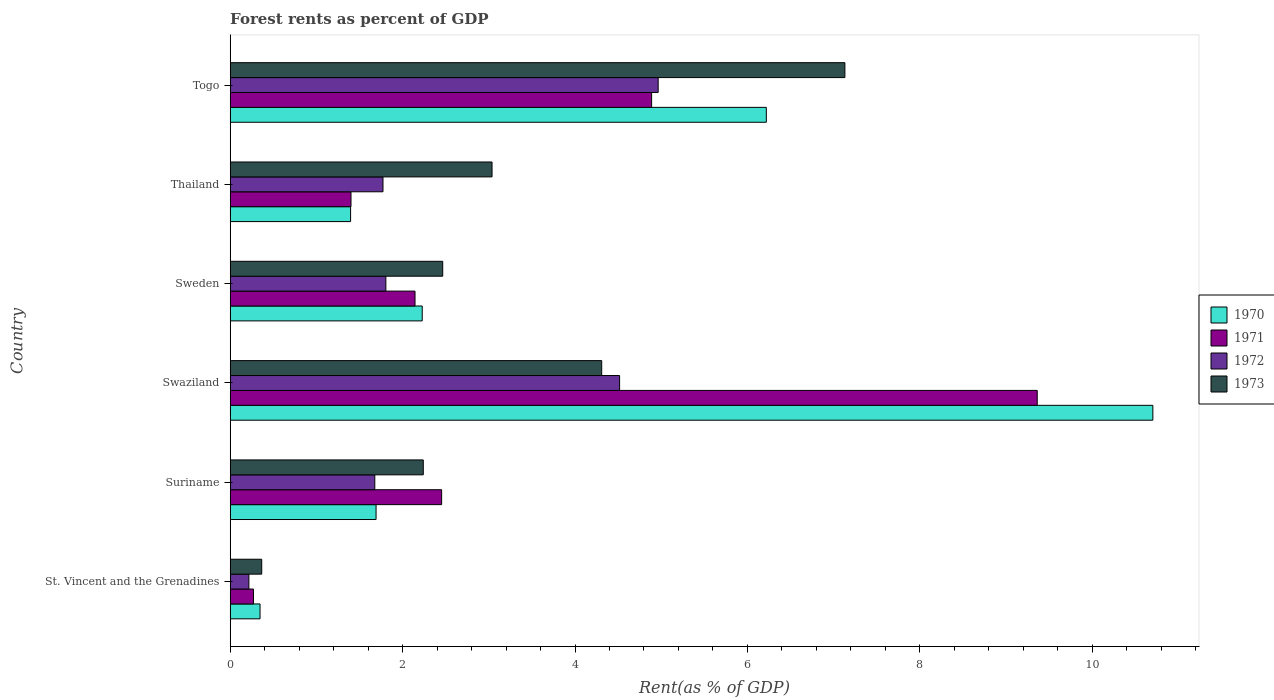How many different coloured bars are there?
Your answer should be very brief. 4. How many groups of bars are there?
Make the answer very short. 6. How many bars are there on the 2nd tick from the bottom?
Offer a very short reply. 4. What is the label of the 4th group of bars from the top?
Keep it short and to the point. Swaziland. In how many cases, is the number of bars for a given country not equal to the number of legend labels?
Give a very brief answer. 0. What is the forest rent in 1973 in St. Vincent and the Grenadines?
Give a very brief answer. 0.37. Across all countries, what is the maximum forest rent in 1970?
Your answer should be very brief. 10.7. Across all countries, what is the minimum forest rent in 1971?
Ensure brevity in your answer.  0.27. In which country was the forest rent in 1972 maximum?
Your answer should be very brief. Togo. In which country was the forest rent in 1972 minimum?
Give a very brief answer. St. Vincent and the Grenadines. What is the total forest rent in 1970 in the graph?
Offer a very short reply. 22.58. What is the difference between the forest rent in 1970 in Suriname and that in Sweden?
Give a very brief answer. -0.54. What is the difference between the forest rent in 1971 in Togo and the forest rent in 1972 in St. Vincent and the Grenadines?
Offer a terse response. 4.67. What is the average forest rent in 1973 per country?
Your answer should be compact. 3.26. What is the difference between the forest rent in 1971 and forest rent in 1970 in Togo?
Give a very brief answer. -1.33. What is the ratio of the forest rent in 1972 in Suriname to that in Swaziland?
Offer a terse response. 0.37. Is the forest rent in 1970 in St. Vincent and the Grenadines less than that in Suriname?
Provide a succinct answer. Yes. What is the difference between the highest and the second highest forest rent in 1970?
Offer a very short reply. 4.48. What is the difference between the highest and the lowest forest rent in 1972?
Your answer should be compact. 4.75. Is it the case that in every country, the sum of the forest rent in 1970 and forest rent in 1971 is greater than the sum of forest rent in 1973 and forest rent in 1972?
Your response must be concise. No. What does the 3rd bar from the bottom in Togo represents?
Offer a terse response. 1972. Is it the case that in every country, the sum of the forest rent in 1970 and forest rent in 1973 is greater than the forest rent in 1971?
Give a very brief answer. Yes. How many bars are there?
Keep it short and to the point. 24. How many countries are there in the graph?
Make the answer very short. 6. Are the values on the major ticks of X-axis written in scientific E-notation?
Your answer should be very brief. No. Does the graph contain grids?
Provide a short and direct response. No. How many legend labels are there?
Make the answer very short. 4. How are the legend labels stacked?
Ensure brevity in your answer.  Vertical. What is the title of the graph?
Provide a succinct answer. Forest rents as percent of GDP. Does "1973" appear as one of the legend labels in the graph?
Your answer should be very brief. Yes. What is the label or title of the X-axis?
Your answer should be compact. Rent(as % of GDP). What is the label or title of the Y-axis?
Provide a short and direct response. Country. What is the Rent(as % of GDP) of 1970 in St. Vincent and the Grenadines?
Offer a terse response. 0.35. What is the Rent(as % of GDP) of 1971 in St. Vincent and the Grenadines?
Keep it short and to the point. 0.27. What is the Rent(as % of GDP) in 1972 in St. Vincent and the Grenadines?
Offer a very short reply. 0.22. What is the Rent(as % of GDP) in 1973 in St. Vincent and the Grenadines?
Provide a short and direct response. 0.37. What is the Rent(as % of GDP) in 1970 in Suriname?
Make the answer very short. 1.69. What is the Rent(as % of GDP) in 1971 in Suriname?
Provide a short and direct response. 2.45. What is the Rent(as % of GDP) in 1972 in Suriname?
Offer a terse response. 1.68. What is the Rent(as % of GDP) in 1973 in Suriname?
Give a very brief answer. 2.24. What is the Rent(as % of GDP) in 1970 in Swaziland?
Keep it short and to the point. 10.7. What is the Rent(as % of GDP) of 1971 in Swaziland?
Keep it short and to the point. 9.36. What is the Rent(as % of GDP) in 1972 in Swaziland?
Offer a very short reply. 4.52. What is the Rent(as % of GDP) of 1973 in Swaziland?
Make the answer very short. 4.31. What is the Rent(as % of GDP) in 1970 in Sweden?
Keep it short and to the point. 2.23. What is the Rent(as % of GDP) of 1971 in Sweden?
Give a very brief answer. 2.14. What is the Rent(as % of GDP) of 1972 in Sweden?
Offer a very short reply. 1.81. What is the Rent(as % of GDP) of 1973 in Sweden?
Ensure brevity in your answer.  2.47. What is the Rent(as % of GDP) in 1970 in Thailand?
Your response must be concise. 1.4. What is the Rent(as % of GDP) in 1971 in Thailand?
Provide a succinct answer. 1.4. What is the Rent(as % of GDP) of 1972 in Thailand?
Your answer should be compact. 1.77. What is the Rent(as % of GDP) in 1973 in Thailand?
Offer a very short reply. 3.04. What is the Rent(as % of GDP) in 1970 in Togo?
Provide a short and direct response. 6.22. What is the Rent(as % of GDP) in 1971 in Togo?
Provide a succinct answer. 4.89. What is the Rent(as % of GDP) in 1972 in Togo?
Provide a short and direct response. 4.96. What is the Rent(as % of GDP) of 1973 in Togo?
Keep it short and to the point. 7.13. Across all countries, what is the maximum Rent(as % of GDP) in 1970?
Give a very brief answer. 10.7. Across all countries, what is the maximum Rent(as % of GDP) in 1971?
Keep it short and to the point. 9.36. Across all countries, what is the maximum Rent(as % of GDP) in 1972?
Offer a very short reply. 4.96. Across all countries, what is the maximum Rent(as % of GDP) in 1973?
Keep it short and to the point. 7.13. Across all countries, what is the minimum Rent(as % of GDP) in 1970?
Your answer should be compact. 0.35. Across all countries, what is the minimum Rent(as % of GDP) in 1971?
Ensure brevity in your answer.  0.27. Across all countries, what is the minimum Rent(as % of GDP) of 1972?
Your response must be concise. 0.22. Across all countries, what is the minimum Rent(as % of GDP) of 1973?
Your answer should be compact. 0.37. What is the total Rent(as % of GDP) in 1970 in the graph?
Make the answer very short. 22.58. What is the total Rent(as % of GDP) in 1971 in the graph?
Offer a very short reply. 20.52. What is the total Rent(as % of GDP) in 1972 in the graph?
Provide a succinct answer. 14.95. What is the total Rent(as % of GDP) of 1973 in the graph?
Your response must be concise. 19.55. What is the difference between the Rent(as % of GDP) of 1970 in St. Vincent and the Grenadines and that in Suriname?
Give a very brief answer. -1.35. What is the difference between the Rent(as % of GDP) of 1971 in St. Vincent and the Grenadines and that in Suriname?
Your answer should be compact. -2.18. What is the difference between the Rent(as % of GDP) of 1972 in St. Vincent and the Grenadines and that in Suriname?
Your answer should be compact. -1.46. What is the difference between the Rent(as % of GDP) of 1973 in St. Vincent and the Grenadines and that in Suriname?
Ensure brevity in your answer.  -1.87. What is the difference between the Rent(as % of GDP) in 1970 in St. Vincent and the Grenadines and that in Swaziland?
Make the answer very short. -10.36. What is the difference between the Rent(as % of GDP) of 1971 in St. Vincent and the Grenadines and that in Swaziland?
Provide a succinct answer. -9.09. What is the difference between the Rent(as % of GDP) in 1972 in St. Vincent and the Grenadines and that in Swaziland?
Provide a succinct answer. -4.3. What is the difference between the Rent(as % of GDP) in 1973 in St. Vincent and the Grenadines and that in Swaziland?
Give a very brief answer. -3.94. What is the difference between the Rent(as % of GDP) of 1970 in St. Vincent and the Grenadines and that in Sweden?
Your response must be concise. -1.88. What is the difference between the Rent(as % of GDP) of 1971 in St. Vincent and the Grenadines and that in Sweden?
Your response must be concise. -1.87. What is the difference between the Rent(as % of GDP) in 1972 in St. Vincent and the Grenadines and that in Sweden?
Ensure brevity in your answer.  -1.59. What is the difference between the Rent(as % of GDP) in 1973 in St. Vincent and the Grenadines and that in Sweden?
Provide a short and direct response. -2.1. What is the difference between the Rent(as % of GDP) of 1970 in St. Vincent and the Grenadines and that in Thailand?
Offer a very short reply. -1.05. What is the difference between the Rent(as % of GDP) of 1971 in St. Vincent and the Grenadines and that in Thailand?
Your answer should be very brief. -1.13. What is the difference between the Rent(as % of GDP) in 1972 in St. Vincent and the Grenadines and that in Thailand?
Give a very brief answer. -1.56. What is the difference between the Rent(as % of GDP) in 1973 in St. Vincent and the Grenadines and that in Thailand?
Ensure brevity in your answer.  -2.67. What is the difference between the Rent(as % of GDP) of 1970 in St. Vincent and the Grenadines and that in Togo?
Your response must be concise. -5.87. What is the difference between the Rent(as % of GDP) in 1971 in St. Vincent and the Grenadines and that in Togo?
Your answer should be very brief. -4.62. What is the difference between the Rent(as % of GDP) in 1972 in St. Vincent and the Grenadines and that in Togo?
Make the answer very short. -4.75. What is the difference between the Rent(as % of GDP) in 1973 in St. Vincent and the Grenadines and that in Togo?
Provide a succinct answer. -6.76. What is the difference between the Rent(as % of GDP) in 1970 in Suriname and that in Swaziland?
Offer a terse response. -9.01. What is the difference between the Rent(as % of GDP) of 1971 in Suriname and that in Swaziland?
Offer a very short reply. -6.91. What is the difference between the Rent(as % of GDP) of 1972 in Suriname and that in Swaziland?
Offer a very short reply. -2.84. What is the difference between the Rent(as % of GDP) of 1973 in Suriname and that in Swaziland?
Ensure brevity in your answer.  -2.07. What is the difference between the Rent(as % of GDP) in 1970 in Suriname and that in Sweden?
Your response must be concise. -0.54. What is the difference between the Rent(as % of GDP) of 1971 in Suriname and that in Sweden?
Provide a succinct answer. 0.31. What is the difference between the Rent(as % of GDP) of 1972 in Suriname and that in Sweden?
Give a very brief answer. -0.13. What is the difference between the Rent(as % of GDP) in 1973 in Suriname and that in Sweden?
Keep it short and to the point. -0.23. What is the difference between the Rent(as % of GDP) of 1970 in Suriname and that in Thailand?
Offer a very short reply. 0.3. What is the difference between the Rent(as % of GDP) of 1971 in Suriname and that in Thailand?
Your answer should be compact. 1.05. What is the difference between the Rent(as % of GDP) in 1972 in Suriname and that in Thailand?
Provide a short and direct response. -0.1. What is the difference between the Rent(as % of GDP) of 1973 in Suriname and that in Thailand?
Ensure brevity in your answer.  -0.8. What is the difference between the Rent(as % of GDP) in 1970 in Suriname and that in Togo?
Provide a succinct answer. -4.53. What is the difference between the Rent(as % of GDP) of 1971 in Suriname and that in Togo?
Your response must be concise. -2.44. What is the difference between the Rent(as % of GDP) of 1972 in Suriname and that in Togo?
Offer a very short reply. -3.29. What is the difference between the Rent(as % of GDP) of 1973 in Suriname and that in Togo?
Make the answer very short. -4.89. What is the difference between the Rent(as % of GDP) in 1970 in Swaziland and that in Sweden?
Your response must be concise. 8.48. What is the difference between the Rent(as % of GDP) in 1971 in Swaziland and that in Sweden?
Make the answer very short. 7.22. What is the difference between the Rent(as % of GDP) in 1972 in Swaziland and that in Sweden?
Make the answer very short. 2.71. What is the difference between the Rent(as % of GDP) of 1973 in Swaziland and that in Sweden?
Your answer should be very brief. 1.84. What is the difference between the Rent(as % of GDP) in 1970 in Swaziland and that in Thailand?
Your answer should be compact. 9.31. What is the difference between the Rent(as % of GDP) of 1971 in Swaziland and that in Thailand?
Make the answer very short. 7.96. What is the difference between the Rent(as % of GDP) of 1972 in Swaziland and that in Thailand?
Your response must be concise. 2.74. What is the difference between the Rent(as % of GDP) in 1973 in Swaziland and that in Thailand?
Provide a succinct answer. 1.27. What is the difference between the Rent(as % of GDP) of 1970 in Swaziland and that in Togo?
Give a very brief answer. 4.48. What is the difference between the Rent(as % of GDP) of 1971 in Swaziland and that in Togo?
Ensure brevity in your answer.  4.47. What is the difference between the Rent(as % of GDP) in 1972 in Swaziland and that in Togo?
Offer a very short reply. -0.45. What is the difference between the Rent(as % of GDP) in 1973 in Swaziland and that in Togo?
Provide a short and direct response. -2.82. What is the difference between the Rent(as % of GDP) of 1970 in Sweden and that in Thailand?
Provide a succinct answer. 0.83. What is the difference between the Rent(as % of GDP) of 1971 in Sweden and that in Thailand?
Provide a succinct answer. 0.74. What is the difference between the Rent(as % of GDP) of 1972 in Sweden and that in Thailand?
Provide a succinct answer. 0.03. What is the difference between the Rent(as % of GDP) of 1973 in Sweden and that in Thailand?
Ensure brevity in your answer.  -0.57. What is the difference between the Rent(as % of GDP) in 1970 in Sweden and that in Togo?
Offer a very short reply. -3.99. What is the difference between the Rent(as % of GDP) of 1971 in Sweden and that in Togo?
Offer a very short reply. -2.74. What is the difference between the Rent(as % of GDP) in 1972 in Sweden and that in Togo?
Offer a very short reply. -3.16. What is the difference between the Rent(as % of GDP) of 1973 in Sweden and that in Togo?
Keep it short and to the point. -4.67. What is the difference between the Rent(as % of GDP) in 1970 in Thailand and that in Togo?
Offer a very short reply. -4.82. What is the difference between the Rent(as % of GDP) in 1971 in Thailand and that in Togo?
Provide a succinct answer. -3.49. What is the difference between the Rent(as % of GDP) of 1972 in Thailand and that in Togo?
Your answer should be compact. -3.19. What is the difference between the Rent(as % of GDP) of 1973 in Thailand and that in Togo?
Keep it short and to the point. -4.09. What is the difference between the Rent(as % of GDP) of 1970 in St. Vincent and the Grenadines and the Rent(as % of GDP) of 1971 in Suriname?
Offer a very short reply. -2.11. What is the difference between the Rent(as % of GDP) in 1970 in St. Vincent and the Grenadines and the Rent(as % of GDP) in 1972 in Suriname?
Offer a terse response. -1.33. What is the difference between the Rent(as % of GDP) of 1970 in St. Vincent and the Grenadines and the Rent(as % of GDP) of 1973 in Suriname?
Ensure brevity in your answer.  -1.89. What is the difference between the Rent(as % of GDP) of 1971 in St. Vincent and the Grenadines and the Rent(as % of GDP) of 1972 in Suriname?
Provide a short and direct response. -1.41. What is the difference between the Rent(as % of GDP) in 1971 in St. Vincent and the Grenadines and the Rent(as % of GDP) in 1973 in Suriname?
Make the answer very short. -1.97. What is the difference between the Rent(as % of GDP) of 1972 in St. Vincent and the Grenadines and the Rent(as % of GDP) of 1973 in Suriname?
Keep it short and to the point. -2.02. What is the difference between the Rent(as % of GDP) in 1970 in St. Vincent and the Grenadines and the Rent(as % of GDP) in 1971 in Swaziland?
Ensure brevity in your answer.  -9.02. What is the difference between the Rent(as % of GDP) of 1970 in St. Vincent and the Grenadines and the Rent(as % of GDP) of 1972 in Swaziland?
Provide a succinct answer. -4.17. What is the difference between the Rent(as % of GDP) of 1970 in St. Vincent and the Grenadines and the Rent(as % of GDP) of 1973 in Swaziland?
Provide a succinct answer. -3.96. What is the difference between the Rent(as % of GDP) of 1971 in St. Vincent and the Grenadines and the Rent(as % of GDP) of 1972 in Swaziland?
Your response must be concise. -4.25. What is the difference between the Rent(as % of GDP) in 1971 in St. Vincent and the Grenadines and the Rent(as % of GDP) in 1973 in Swaziland?
Offer a very short reply. -4.04. What is the difference between the Rent(as % of GDP) of 1972 in St. Vincent and the Grenadines and the Rent(as % of GDP) of 1973 in Swaziland?
Your answer should be compact. -4.09. What is the difference between the Rent(as % of GDP) in 1970 in St. Vincent and the Grenadines and the Rent(as % of GDP) in 1971 in Sweden?
Your answer should be compact. -1.8. What is the difference between the Rent(as % of GDP) of 1970 in St. Vincent and the Grenadines and the Rent(as % of GDP) of 1972 in Sweden?
Your response must be concise. -1.46. What is the difference between the Rent(as % of GDP) of 1970 in St. Vincent and the Grenadines and the Rent(as % of GDP) of 1973 in Sweden?
Give a very brief answer. -2.12. What is the difference between the Rent(as % of GDP) in 1971 in St. Vincent and the Grenadines and the Rent(as % of GDP) in 1972 in Sweden?
Your response must be concise. -1.54. What is the difference between the Rent(as % of GDP) of 1971 in St. Vincent and the Grenadines and the Rent(as % of GDP) of 1973 in Sweden?
Offer a very short reply. -2.2. What is the difference between the Rent(as % of GDP) of 1972 in St. Vincent and the Grenadines and the Rent(as % of GDP) of 1973 in Sweden?
Make the answer very short. -2.25. What is the difference between the Rent(as % of GDP) of 1970 in St. Vincent and the Grenadines and the Rent(as % of GDP) of 1971 in Thailand?
Offer a terse response. -1.06. What is the difference between the Rent(as % of GDP) of 1970 in St. Vincent and the Grenadines and the Rent(as % of GDP) of 1972 in Thailand?
Your response must be concise. -1.43. What is the difference between the Rent(as % of GDP) of 1970 in St. Vincent and the Grenadines and the Rent(as % of GDP) of 1973 in Thailand?
Provide a succinct answer. -2.69. What is the difference between the Rent(as % of GDP) of 1971 in St. Vincent and the Grenadines and the Rent(as % of GDP) of 1972 in Thailand?
Provide a succinct answer. -1.5. What is the difference between the Rent(as % of GDP) in 1971 in St. Vincent and the Grenadines and the Rent(as % of GDP) in 1973 in Thailand?
Offer a terse response. -2.77. What is the difference between the Rent(as % of GDP) in 1972 in St. Vincent and the Grenadines and the Rent(as % of GDP) in 1973 in Thailand?
Provide a succinct answer. -2.82. What is the difference between the Rent(as % of GDP) in 1970 in St. Vincent and the Grenadines and the Rent(as % of GDP) in 1971 in Togo?
Provide a short and direct response. -4.54. What is the difference between the Rent(as % of GDP) in 1970 in St. Vincent and the Grenadines and the Rent(as % of GDP) in 1972 in Togo?
Give a very brief answer. -4.62. What is the difference between the Rent(as % of GDP) of 1970 in St. Vincent and the Grenadines and the Rent(as % of GDP) of 1973 in Togo?
Provide a short and direct response. -6.78. What is the difference between the Rent(as % of GDP) of 1971 in St. Vincent and the Grenadines and the Rent(as % of GDP) of 1972 in Togo?
Your answer should be compact. -4.69. What is the difference between the Rent(as % of GDP) in 1971 in St. Vincent and the Grenadines and the Rent(as % of GDP) in 1973 in Togo?
Offer a terse response. -6.86. What is the difference between the Rent(as % of GDP) in 1972 in St. Vincent and the Grenadines and the Rent(as % of GDP) in 1973 in Togo?
Provide a succinct answer. -6.91. What is the difference between the Rent(as % of GDP) in 1970 in Suriname and the Rent(as % of GDP) in 1971 in Swaziland?
Your response must be concise. -7.67. What is the difference between the Rent(as % of GDP) of 1970 in Suriname and the Rent(as % of GDP) of 1972 in Swaziland?
Offer a terse response. -2.82. What is the difference between the Rent(as % of GDP) of 1970 in Suriname and the Rent(as % of GDP) of 1973 in Swaziland?
Your answer should be compact. -2.62. What is the difference between the Rent(as % of GDP) in 1971 in Suriname and the Rent(as % of GDP) in 1972 in Swaziland?
Your response must be concise. -2.06. What is the difference between the Rent(as % of GDP) in 1971 in Suriname and the Rent(as % of GDP) in 1973 in Swaziland?
Give a very brief answer. -1.86. What is the difference between the Rent(as % of GDP) in 1972 in Suriname and the Rent(as % of GDP) in 1973 in Swaziland?
Ensure brevity in your answer.  -2.63. What is the difference between the Rent(as % of GDP) of 1970 in Suriname and the Rent(as % of GDP) of 1971 in Sweden?
Give a very brief answer. -0.45. What is the difference between the Rent(as % of GDP) of 1970 in Suriname and the Rent(as % of GDP) of 1972 in Sweden?
Make the answer very short. -0.11. What is the difference between the Rent(as % of GDP) in 1970 in Suriname and the Rent(as % of GDP) in 1973 in Sweden?
Your answer should be compact. -0.77. What is the difference between the Rent(as % of GDP) of 1971 in Suriname and the Rent(as % of GDP) of 1972 in Sweden?
Offer a terse response. 0.65. What is the difference between the Rent(as % of GDP) in 1971 in Suriname and the Rent(as % of GDP) in 1973 in Sweden?
Offer a very short reply. -0.01. What is the difference between the Rent(as % of GDP) in 1972 in Suriname and the Rent(as % of GDP) in 1973 in Sweden?
Keep it short and to the point. -0.79. What is the difference between the Rent(as % of GDP) of 1970 in Suriname and the Rent(as % of GDP) of 1971 in Thailand?
Your answer should be very brief. 0.29. What is the difference between the Rent(as % of GDP) in 1970 in Suriname and the Rent(as % of GDP) in 1972 in Thailand?
Offer a terse response. -0.08. What is the difference between the Rent(as % of GDP) of 1970 in Suriname and the Rent(as % of GDP) of 1973 in Thailand?
Provide a short and direct response. -1.35. What is the difference between the Rent(as % of GDP) in 1971 in Suriname and the Rent(as % of GDP) in 1972 in Thailand?
Your answer should be compact. 0.68. What is the difference between the Rent(as % of GDP) of 1971 in Suriname and the Rent(as % of GDP) of 1973 in Thailand?
Your response must be concise. -0.58. What is the difference between the Rent(as % of GDP) in 1972 in Suriname and the Rent(as % of GDP) in 1973 in Thailand?
Make the answer very short. -1.36. What is the difference between the Rent(as % of GDP) of 1970 in Suriname and the Rent(as % of GDP) of 1971 in Togo?
Your answer should be very brief. -3.2. What is the difference between the Rent(as % of GDP) in 1970 in Suriname and the Rent(as % of GDP) in 1972 in Togo?
Your response must be concise. -3.27. What is the difference between the Rent(as % of GDP) of 1970 in Suriname and the Rent(as % of GDP) of 1973 in Togo?
Make the answer very short. -5.44. What is the difference between the Rent(as % of GDP) in 1971 in Suriname and the Rent(as % of GDP) in 1972 in Togo?
Ensure brevity in your answer.  -2.51. What is the difference between the Rent(as % of GDP) of 1971 in Suriname and the Rent(as % of GDP) of 1973 in Togo?
Give a very brief answer. -4.68. What is the difference between the Rent(as % of GDP) in 1972 in Suriname and the Rent(as % of GDP) in 1973 in Togo?
Make the answer very short. -5.45. What is the difference between the Rent(as % of GDP) in 1970 in Swaziland and the Rent(as % of GDP) in 1971 in Sweden?
Ensure brevity in your answer.  8.56. What is the difference between the Rent(as % of GDP) in 1970 in Swaziland and the Rent(as % of GDP) in 1972 in Sweden?
Offer a terse response. 8.9. What is the difference between the Rent(as % of GDP) of 1970 in Swaziland and the Rent(as % of GDP) of 1973 in Sweden?
Offer a very short reply. 8.24. What is the difference between the Rent(as % of GDP) of 1971 in Swaziland and the Rent(as % of GDP) of 1972 in Sweden?
Your response must be concise. 7.56. What is the difference between the Rent(as % of GDP) in 1971 in Swaziland and the Rent(as % of GDP) in 1973 in Sweden?
Your answer should be compact. 6.9. What is the difference between the Rent(as % of GDP) of 1972 in Swaziland and the Rent(as % of GDP) of 1973 in Sweden?
Provide a short and direct response. 2.05. What is the difference between the Rent(as % of GDP) of 1970 in Swaziland and the Rent(as % of GDP) of 1971 in Thailand?
Offer a terse response. 9.3. What is the difference between the Rent(as % of GDP) in 1970 in Swaziland and the Rent(as % of GDP) in 1972 in Thailand?
Your answer should be compact. 8.93. What is the difference between the Rent(as % of GDP) in 1970 in Swaziland and the Rent(as % of GDP) in 1973 in Thailand?
Your answer should be very brief. 7.67. What is the difference between the Rent(as % of GDP) of 1971 in Swaziland and the Rent(as % of GDP) of 1972 in Thailand?
Provide a succinct answer. 7.59. What is the difference between the Rent(as % of GDP) in 1971 in Swaziland and the Rent(as % of GDP) in 1973 in Thailand?
Provide a succinct answer. 6.32. What is the difference between the Rent(as % of GDP) of 1972 in Swaziland and the Rent(as % of GDP) of 1973 in Thailand?
Offer a terse response. 1.48. What is the difference between the Rent(as % of GDP) in 1970 in Swaziland and the Rent(as % of GDP) in 1971 in Togo?
Offer a very short reply. 5.81. What is the difference between the Rent(as % of GDP) of 1970 in Swaziland and the Rent(as % of GDP) of 1972 in Togo?
Offer a terse response. 5.74. What is the difference between the Rent(as % of GDP) in 1970 in Swaziland and the Rent(as % of GDP) in 1973 in Togo?
Provide a short and direct response. 3.57. What is the difference between the Rent(as % of GDP) of 1971 in Swaziland and the Rent(as % of GDP) of 1972 in Togo?
Offer a very short reply. 4.4. What is the difference between the Rent(as % of GDP) of 1971 in Swaziland and the Rent(as % of GDP) of 1973 in Togo?
Offer a terse response. 2.23. What is the difference between the Rent(as % of GDP) in 1972 in Swaziland and the Rent(as % of GDP) in 1973 in Togo?
Ensure brevity in your answer.  -2.61. What is the difference between the Rent(as % of GDP) of 1970 in Sweden and the Rent(as % of GDP) of 1971 in Thailand?
Give a very brief answer. 0.83. What is the difference between the Rent(as % of GDP) of 1970 in Sweden and the Rent(as % of GDP) of 1972 in Thailand?
Provide a short and direct response. 0.46. What is the difference between the Rent(as % of GDP) of 1970 in Sweden and the Rent(as % of GDP) of 1973 in Thailand?
Make the answer very short. -0.81. What is the difference between the Rent(as % of GDP) in 1971 in Sweden and the Rent(as % of GDP) in 1972 in Thailand?
Your answer should be very brief. 0.37. What is the difference between the Rent(as % of GDP) in 1971 in Sweden and the Rent(as % of GDP) in 1973 in Thailand?
Keep it short and to the point. -0.89. What is the difference between the Rent(as % of GDP) in 1972 in Sweden and the Rent(as % of GDP) in 1973 in Thailand?
Ensure brevity in your answer.  -1.23. What is the difference between the Rent(as % of GDP) of 1970 in Sweden and the Rent(as % of GDP) of 1971 in Togo?
Provide a short and direct response. -2.66. What is the difference between the Rent(as % of GDP) of 1970 in Sweden and the Rent(as % of GDP) of 1972 in Togo?
Provide a succinct answer. -2.74. What is the difference between the Rent(as % of GDP) in 1970 in Sweden and the Rent(as % of GDP) in 1973 in Togo?
Offer a terse response. -4.9. What is the difference between the Rent(as % of GDP) of 1971 in Sweden and the Rent(as % of GDP) of 1972 in Togo?
Keep it short and to the point. -2.82. What is the difference between the Rent(as % of GDP) of 1971 in Sweden and the Rent(as % of GDP) of 1973 in Togo?
Provide a succinct answer. -4.99. What is the difference between the Rent(as % of GDP) in 1972 in Sweden and the Rent(as % of GDP) in 1973 in Togo?
Offer a very short reply. -5.32. What is the difference between the Rent(as % of GDP) of 1970 in Thailand and the Rent(as % of GDP) of 1971 in Togo?
Your answer should be very brief. -3.49. What is the difference between the Rent(as % of GDP) in 1970 in Thailand and the Rent(as % of GDP) in 1972 in Togo?
Keep it short and to the point. -3.57. What is the difference between the Rent(as % of GDP) of 1970 in Thailand and the Rent(as % of GDP) of 1973 in Togo?
Provide a succinct answer. -5.73. What is the difference between the Rent(as % of GDP) of 1971 in Thailand and the Rent(as % of GDP) of 1972 in Togo?
Provide a succinct answer. -3.56. What is the difference between the Rent(as % of GDP) in 1971 in Thailand and the Rent(as % of GDP) in 1973 in Togo?
Keep it short and to the point. -5.73. What is the difference between the Rent(as % of GDP) in 1972 in Thailand and the Rent(as % of GDP) in 1973 in Togo?
Offer a terse response. -5.36. What is the average Rent(as % of GDP) in 1970 per country?
Your response must be concise. 3.76. What is the average Rent(as % of GDP) in 1971 per country?
Ensure brevity in your answer.  3.42. What is the average Rent(as % of GDP) of 1972 per country?
Ensure brevity in your answer.  2.49. What is the average Rent(as % of GDP) of 1973 per country?
Offer a very short reply. 3.26. What is the difference between the Rent(as % of GDP) in 1970 and Rent(as % of GDP) in 1971 in St. Vincent and the Grenadines?
Keep it short and to the point. 0.08. What is the difference between the Rent(as % of GDP) of 1970 and Rent(as % of GDP) of 1972 in St. Vincent and the Grenadines?
Your answer should be very brief. 0.13. What is the difference between the Rent(as % of GDP) of 1970 and Rent(as % of GDP) of 1973 in St. Vincent and the Grenadines?
Ensure brevity in your answer.  -0.02. What is the difference between the Rent(as % of GDP) in 1971 and Rent(as % of GDP) in 1972 in St. Vincent and the Grenadines?
Make the answer very short. 0.05. What is the difference between the Rent(as % of GDP) in 1971 and Rent(as % of GDP) in 1973 in St. Vincent and the Grenadines?
Give a very brief answer. -0.1. What is the difference between the Rent(as % of GDP) of 1972 and Rent(as % of GDP) of 1973 in St. Vincent and the Grenadines?
Give a very brief answer. -0.15. What is the difference between the Rent(as % of GDP) of 1970 and Rent(as % of GDP) of 1971 in Suriname?
Give a very brief answer. -0.76. What is the difference between the Rent(as % of GDP) in 1970 and Rent(as % of GDP) in 1972 in Suriname?
Your response must be concise. 0.01. What is the difference between the Rent(as % of GDP) in 1970 and Rent(as % of GDP) in 1973 in Suriname?
Give a very brief answer. -0.55. What is the difference between the Rent(as % of GDP) in 1971 and Rent(as % of GDP) in 1972 in Suriname?
Offer a terse response. 0.78. What is the difference between the Rent(as % of GDP) of 1971 and Rent(as % of GDP) of 1973 in Suriname?
Provide a short and direct response. 0.21. What is the difference between the Rent(as % of GDP) of 1972 and Rent(as % of GDP) of 1973 in Suriname?
Make the answer very short. -0.56. What is the difference between the Rent(as % of GDP) in 1970 and Rent(as % of GDP) in 1971 in Swaziland?
Ensure brevity in your answer.  1.34. What is the difference between the Rent(as % of GDP) in 1970 and Rent(as % of GDP) in 1972 in Swaziland?
Your answer should be very brief. 6.19. What is the difference between the Rent(as % of GDP) in 1970 and Rent(as % of GDP) in 1973 in Swaziland?
Provide a short and direct response. 6.39. What is the difference between the Rent(as % of GDP) of 1971 and Rent(as % of GDP) of 1972 in Swaziland?
Ensure brevity in your answer.  4.84. What is the difference between the Rent(as % of GDP) of 1971 and Rent(as % of GDP) of 1973 in Swaziland?
Provide a short and direct response. 5.05. What is the difference between the Rent(as % of GDP) in 1972 and Rent(as % of GDP) in 1973 in Swaziland?
Provide a succinct answer. 0.21. What is the difference between the Rent(as % of GDP) in 1970 and Rent(as % of GDP) in 1971 in Sweden?
Offer a very short reply. 0.08. What is the difference between the Rent(as % of GDP) in 1970 and Rent(as % of GDP) in 1972 in Sweden?
Provide a succinct answer. 0.42. What is the difference between the Rent(as % of GDP) in 1970 and Rent(as % of GDP) in 1973 in Sweden?
Your answer should be very brief. -0.24. What is the difference between the Rent(as % of GDP) in 1971 and Rent(as % of GDP) in 1972 in Sweden?
Provide a short and direct response. 0.34. What is the difference between the Rent(as % of GDP) of 1971 and Rent(as % of GDP) of 1973 in Sweden?
Your answer should be very brief. -0.32. What is the difference between the Rent(as % of GDP) in 1972 and Rent(as % of GDP) in 1973 in Sweden?
Keep it short and to the point. -0.66. What is the difference between the Rent(as % of GDP) in 1970 and Rent(as % of GDP) in 1971 in Thailand?
Provide a short and direct response. -0. What is the difference between the Rent(as % of GDP) in 1970 and Rent(as % of GDP) in 1972 in Thailand?
Give a very brief answer. -0.38. What is the difference between the Rent(as % of GDP) of 1970 and Rent(as % of GDP) of 1973 in Thailand?
Your answer should be compact. -1.64. What is the difference between the Rent(as % of GDP) of 1971 and Rent(as % of GDP) of 1972 in Thailand?
Provide a short and direct response. -0.37. What is the difference between the Rent(as % of GDP) of 1971 and Rent(as % of GDP) of 1973 in Thailand?
Your answer should be compact. -1.64. What is the difference between the Rent(as % of GDP) of 1972 and Rent(as % of GDP) of 1973 in Thailand?
Ensure brevity in your answer.  -1.26. What is the difference between the Rent(as % of GDP) in 1970 and Rent(as % of GDP) in 1971 in Togo?
Offer a terse response. 1.33. What is the difference between the Rent(as % of GDP) in 1970 and Rent(as % of GDP) in 1972 in Togo?
Your response must be concise. 1.25. What is the difference between the Rent(as % of GDP) of 1970 and Rent(as % of GDP) of 1973 in Togo?
Make the answer very short. -0.91. What is the difference between the Rent(as % of GDP) in 1971 and Rent(as % of GDP) in 1972 in Togo?
Ensure brevity in your answer.  -0.08. What is the difference between the Rent(as % of GDP) in 1971 and Rent(as % of GDP) in 1973 in Togo?
Keep it short and to the point. -2.24. What is the difference between the Rent(as % of GDP) in 1972 and Rent(as % of GDP) in 1973 in Togo?
Give a very brief answer. -2.17. What is the ratio of the Rent(as % of GDP) in 1970 in St. Vincent and the Grenadines to that in Suriname?
Provide a succinct answer. 0.2. What is the ratio of the Rent(as % of GDP) of 1971 in St. Vincent and the Grenadines to that in Suriname?
Your response must be concise. 0.11. What is the ratio of the Rent(as % of GDP) of 1972 in St. Vincent and the Grenadines to that in Suriname?
Offer a terse response. 0.13. What is the ratio of the Rent(as % of GDP) in 1973 in St. Vincent and the Grenadines to that in Suriname?
Provide a succinct answer. 0.16. What is the ratio of the Rent(as % of GDP) of 1970 in St. Vincent and the Grenadines to that in Swaziland?
Ensure brevity in your answer.  0.03. What is the ratio of the Rent(as % of GDP) in 1971 in St. Vincent and the Grenadines to that in Swaziland?
Offer a very short reply. 0.03. What is the ratio of the Rent(as % of GDP) of 1972 in St. Vincent and the Grenadines to that in Swaziland?
Give a very brief answer. 0.05. What is the ratio of the Rent(as % of GDP) in 1973 in St. Vincent and the Grenadines to that in Swaziland?
Your answer should be compact. 0.08. What is the ratio of the Rent(as % of GDP) in 1970 in St. Vincent and the Grenadines to that in Sweden?
Offer a terse response. 0.16. What is the ratio of the Rent(as % of GDP) in 1971 in St. Vincent and the Grenadines to that in Sweden?
Your answer should be very brief. 0.13. What is the ratio of the Rent(as % of GDP) in 1972 in St. Vincent and the Grenadines to that in Sweden?
Your answer should be very brief. 0.12. What is the ratio of the Rent(as % of GDP) of 1973 in St. Vincent and the Grenadines to that in Sweden?
Offer a terse response. 0.15. What is the ratio of the Rent(as % of GDP) of 1970 in St. Vincent and the Grenadines to that in Thailand?
Your answer should be very brief. 0.25. What is the ratio of the Rent(as % of GDP) of 1971 in St. Vincent and the Grenadines to that in Thailand?
Offer a very short reply. 0.19. What is the ratio of the Rent(as % of GDP) of 1972 in St. Vincent and the Grenadines to that in Thailand?
Offer a very short reply. 0.12. What is the ratio of the Rent(as % of GDP) in 1973 in St. Vincent and the Grenadines to that in Thailand?
Your answer should be compact. 0.12. What is the ratio of the Rent(as % of GDP) of 1970 in St. Vincent and the Grenadines to that in Togo?
Offer a very short reply. 0.06. What is the ratio of the Rent(as % of GDP) in 1971 in St. Vincent and the Grenadines to that in Togo?
Provide a succinct answer. 0.06. What is the ratio of the Rent(as % of GDP) in 1972 in St. Vincent and the Grenadines to that in Togo?
Offer a very short reply. 0.04. What is the ratio of the Rent(as % of GDP) in 1973 in St. Vincent and the Grenadines to that in Togo?
Offer a very short reply. 0.05. What is the ratio of the Rent(as % of GDP) in 1970 in Suriname to that in Swaziland?
Your response must be concise. 0.16. What is the ratio of the Rent(as % of GDP) of 1971 in Suriname to that in Swaziland?
Your answer should be very brief. 0.26. What is the ratio of the Rent(as % of GDP) of 1972 in Suriname to that in Swaziland?
Ensure brevity in your answer.  0.37. What is the ratio of the Rent(as % of GDP) of 1973 in Suriname to that in Swaziland?
Provide a succinct answer. 0.52. What is the ratio of the Rent(as % of GDP) of 1970 in Suriname to that in Sweden?
Offer a very short reply. 0.76. What is the ratio of the Rent(as % of GDP) in 1971 in Suriname to that in Sweden?
Your answer should be compact. 1.14. What is the ratio of the Rent(as % of GDP) of 1972 in Suriname to that in Sweden?
Provide a succinct answer. 0.93. What is the ratio of the Rent(as % of GDP) of 1973 in Suriname to that in Sweden?
Provide a succinct answer. 0.91. What is the ratio of the Rent(as % of GDP) of 1970 in Suriname to that in Thailand?
Provide a short and direct response. 1.21. What is the ratio of the Rent(as % of GDP) of 1971 in Suriname to that in Thailand?
Your answer should be very brief. 1.75. What is the ratio of the Rent(as % of GDP) of 1972 in Suriname to that in Thailand?
Your answer should be very brief. 0.95. What is the ratio of the Rent(as % of GDP) in 1973 in Suriname to that in Thailand?
Make the answer very short. 0.74. What is the ratio of the Rent(as % of GDP) of 1970 in Suriname to that in Togo?
Give a very brief answer. 0.27. What is the ratio of the Rent(as % of GDP) in 1971 in Suriname to that in Togo?
Keep it short and to the point. 0.5. What is the ratio of the Rent(as % of GDP) in 1972 in Suriname to that in Togo?
Offer a very short reply. 0.34. What is the ratio of the Rent(as % of GDP) in 1973 in Suriname to that in Togo?
Your answer should be very brief. 0.31. What is the ratio of the Rent(as % of GDP) in 1970 in Swaziland to that in Sweden?
Provide a short and direct response. 4.8. What is the ratio of the Rent(as % of GDP) in 1971 in Swaziland to that in Sweden?
Keep it short and to the point. 4.37. What is the ratio of the Rent(as % of GDP) of 1972 in Swaziland to that in Sweden?
Give a very brief answer. 2.5. What is the ratio of the Rent(as % of GDP) of 1973 in Swaziland to that in Sweden?
Make the answer very short. 1.75. What is the ratio of the Rent(as % of GDP) in 1970 in Swaziland to that in Thailand?
Keep it short and to the point. 7.66. What is the ratio of the Rent(as % of GDP) of 1971 in Swaziland to that in Thailand?
Your answer should be compact. 6.68. What is the ratio of the Rent(as % of GDP) in 1972 in Swaziland to that in Thailand?
Keep it short and to the point. 2.55. What is the ratio of the Rent(as % of GDP) in 1973 in Swaziland to that in Thailand?
Offer a terse response. 1.42. What is the ratio of the Rent(as % of GDP) in 1970 in Swaziland to that in Togo?
Ensure brevity in your answer.  1.72. What is the ratio of the Rent(as % of GDP) of 1971 in Swaziland to that in Togo?
Give a very brief answer. 1.92. What is the ratio of the Rent(as % of GDP) of 1972 in Swaziland to that in Togo?
Give a very brief answer. 0.91. What is the ratio of the Rent(as % of GDP) of 1973 in Swaziland to that in Togo?
Offer a terse response. 0.6. What is the ratio of the Rent(as % of GDP) of 1970 in Sweden to that in Thailand?
Offer a terse response. 1.59. What is the ratio of the Rent(as % of GDP) in 1971 in Sweden to that in Thailand?
Your answer should be very brief. 1.53. What is the ratio of the Rent(as % of GDP) in 1972 in Sweden to that in Thailand?
Ensure brevity in your answer.  1.02. What is the ratio of the Rent(as % of GDP) in 1973 in Sweden to that in Thailand?
Your answer should be compact. 0.81. What is the ratio of the Rent(as % of GDP) of 1970 in Sweden to that in Togo?
Offer a terse response. 0.36. What is the ratio of the Rent(as % of GDP) of 1971 in Sweden to that in Togo?
Keep it short and to the point. 0.44. What is the ratio of the Rent(as % of GDP) in 1972 in Sweden to that in Togo?
Your response must be concise. 0.36. What is the ratio of the Rent(as % of GDP) of 1973 in Sweden to that in Togo?
Provide a short and direct response. 0.35. What is the ratio of the Rent(as % of GDP) of 1970 in Thailand to that in Togo?
Your answer should be very brief. 0.22. What is the ratio of the Rent(as % of GDP) of 1971 in Thailand to that in Togo?
Your response must be concise. 0.29. What is the ratio of the Rent(as % of GDP) in 1972 in Thailand to that in Togo?
Provide a succinct answer. 0.36. What is the ratio of the Rent(as % of GDP) of 1973 in Thailand to that in Togo?
Provide a succinct answer. 0.43. What is the difference between the highest and the second highest Rent(as % of GDP) of 1970?
Offer a very short reply. 4.48. What is the difference between the highest and the second highest Rent(as % of GDP) of 1971?
Offer a very short reply. 4.47. What is the difference between the highest and the second highest Rent(as % of GDP) of 1972?
Provide a short and direct response. 0.45. What is the difference between the highest and the second highest Rent(as % of GDP) in 1973?
Your answer should be compact. 2.82. What is the difference between the highest and the lowest Rent(as % of GDP) in 1970?
Give a very brief answer. 10.36. What is the difference between the highest and the lowest Rent(as % of GDP) in 1971?
Provide a succinct answer. 9.09. What is the difference between the highest and the lowest Rent(as % of GDP) in 1972?
Your answer should be compact. 4.75. What is the difference between the highest and the lowest Rent(as % of GDP) of 1973?
Keep it short and to the point. 6.76. 